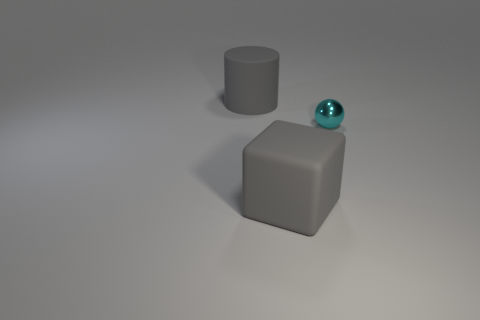Add 2 large blue balls. How many objects exist? 5 Subtract 1 cubes. How many cubes are left? 0 Subtract all cylinders. How many objects are left? 2 Add 1 rubber blocks. How many rubber blocks are left? 2 Add 2 big rubber cubes. How many big rubber cubes exist? 3 Subtract 0 brown cylinders. How many objects are left? 3 Subtract all green cubes. Subtract all cyan spheres. How many cubes are left? 1 Subtract all balls. Subtract all tiny spheres. How many objects are left? 1 